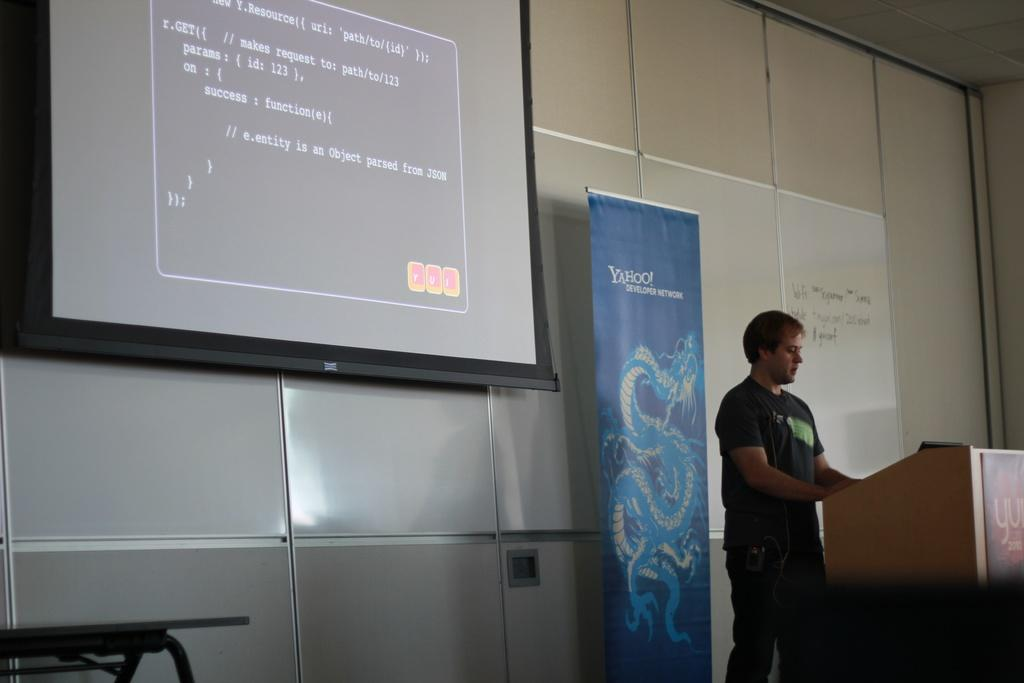Provide a one-sentence caption for the provided image. A technology teacher gives a lecture standing in front of a Yahoo sign while using a projector for his lesson. 